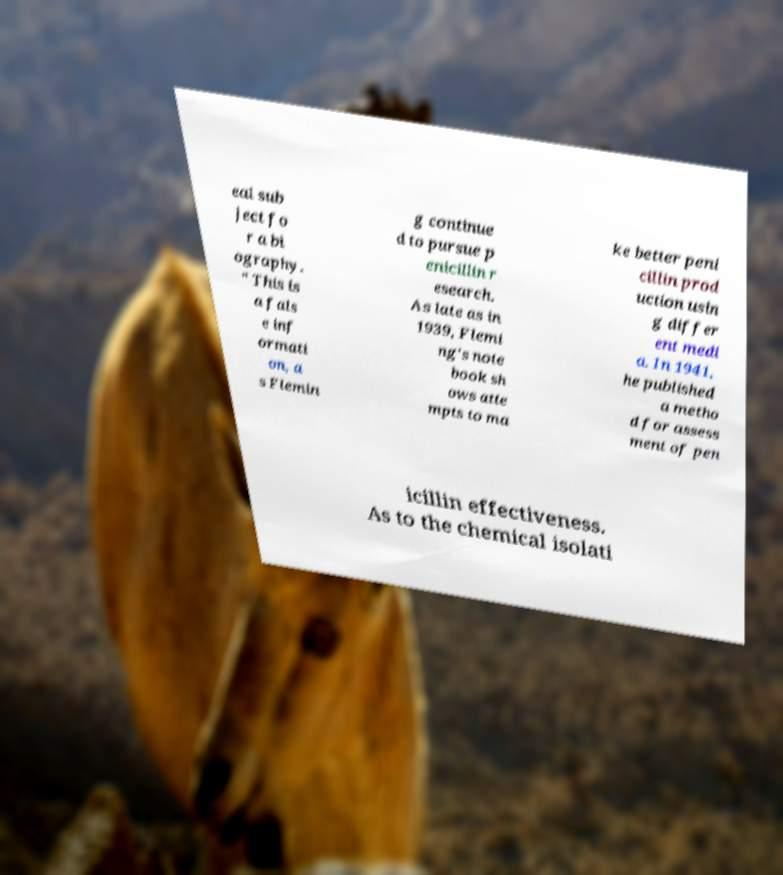Could you extract and type out the text from this image? eal sub ject fo r a bi ography. " This is a fals e inf ormati on, a s Flemin g continue d to pursue p enicillin r esearch. As late as in 1939, Flemi ng's note book sh ows atte mpts to ma ke better peni cillin prod uction usin g differ ent medi a. In 1941, he published a metho d for assess ment of pen icillin effectiveness. As to the chemical isolati 